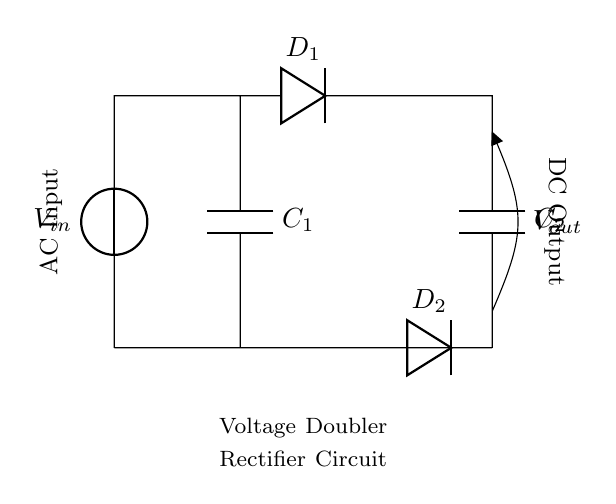What type of circuit is this? This is a voltage doubler rectifier circuit, characterized by its use of capacitors and diodes to effectively double the input AC voltage.
Answer: Voltage doubler rectifier How many capacitors are in the circuit? There are two capacitors, labeled C1 and C2, that store electrical energy in the circuit.
Answer: Two What are the components connected to the output? The components connected to the output are C2, D2, and the connecting lines to Vout; these work together to provide the output voltage.
Answer: C2, D2 What is the function of the diodes in this circuit? The diodes, D1 and D2, allow current to flow in one direction while blocking it from flowing in the opposite direction, crucial for rectification.
Answer: Rectification What is the relationship between the input and output voltage? The output voltage is approximately double the input voltage due to the capacitive and rectifying action of the circuit; hence it functions as a voltage doubler.
Answer: Double What does the label 'AC Input' indicate? The label 'AC Input' indicates that the circuit is designed to receive alternating current, which is then processed to produce a direct current output.
Answer: Alternating current What happens if one of the diodes fails? If one of the diodes fails, it will disrupt the rectification process, leading to insufficient voltage at the output, hence defeating the purpose of voltage doubling.
Answer: Insufficient voltage 